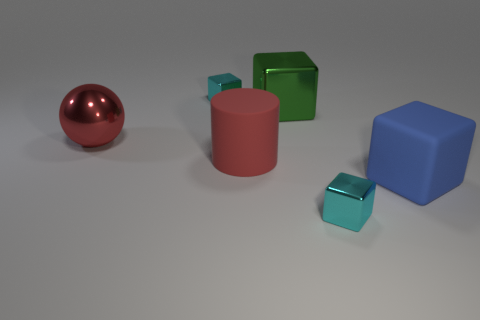Can you describe the shapes and colors of the objects in the image? Certainly! The image showcases a collection of geometric shapes. There's a large red metallic sphere, a red cylinder, and both large and small cubes in blue and green colors. The smaller cubes seem slightly translucent, while the larger ones are opaque. 